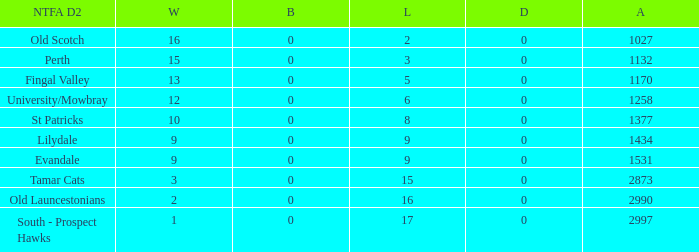What is the lowest number of against of NTFA Div 2 Fingal Valley? 1170.0. 